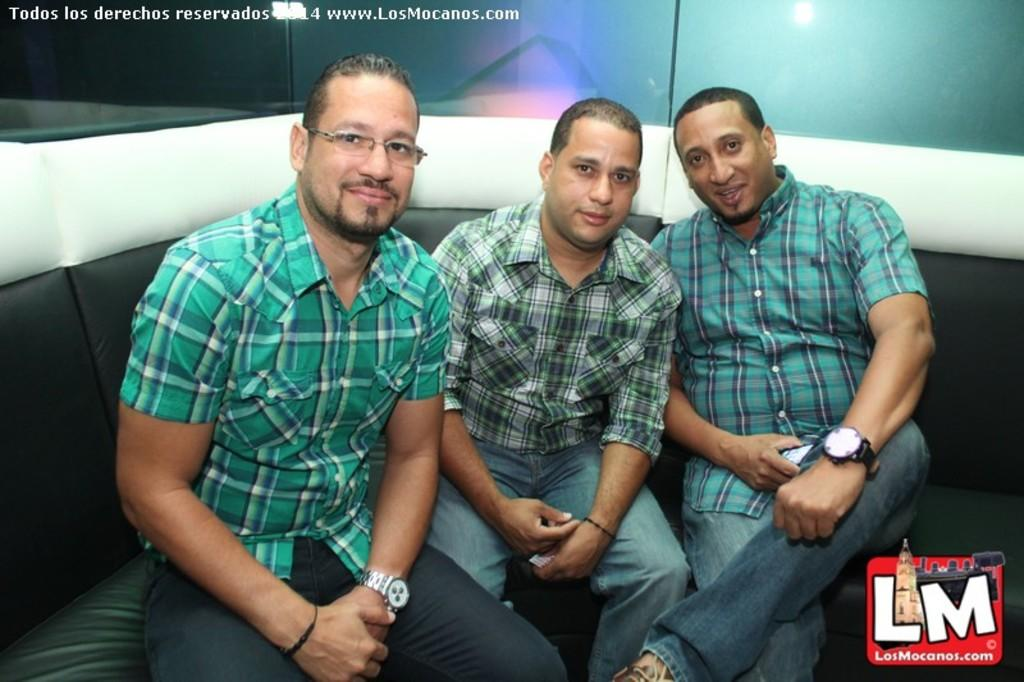How many people are in the image? There are three persons in the image. What are the persons wearing? The persons are wearing clothes. Where are the persons sitting? The persons are sitting on a sofa. Can you describe the person on the left side of the image? The person on the left side of the image is wearing spectacles. What type of thread is being used to create the point of division between the persons in the image? There is no thread or division between the persons in the image; they are simply sitting together on a sofa. 